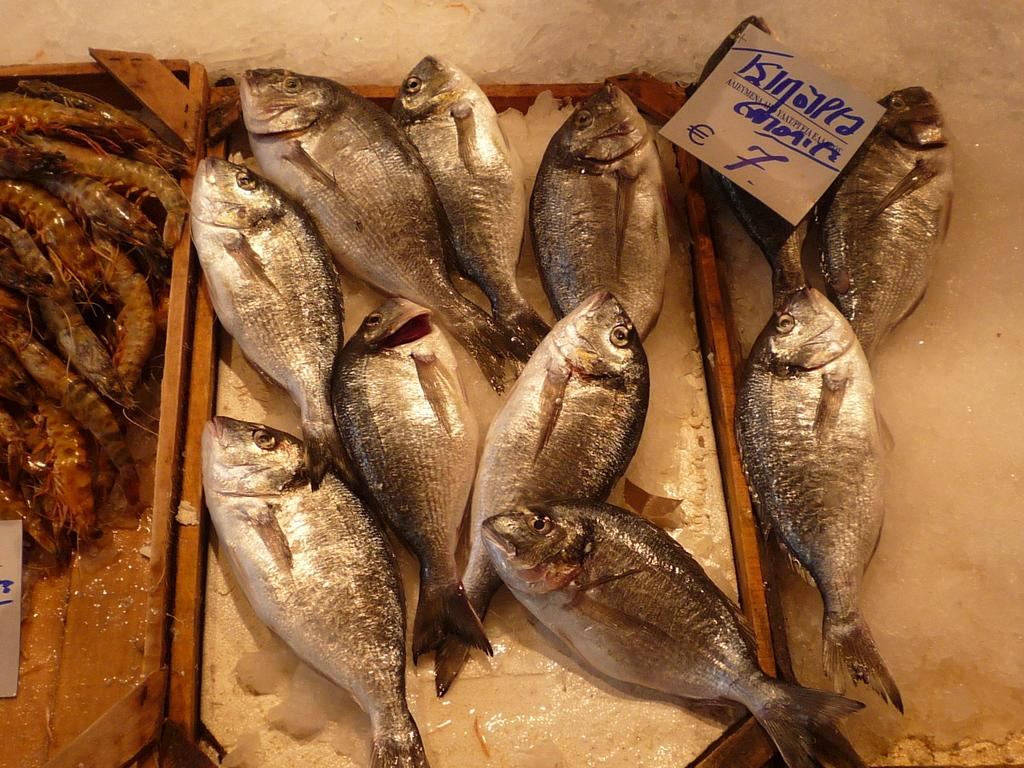What type of seafood can be seen on the wooden trays in the image? There are fishes and shrimps on the wooden trays in the image. How are the wooden trays being kept cool? The wooden trays are on ice in the image. What is located on the right side of the wooden trays? There is a paper on the right side of the trays. What type of watch is the beggar wearing in the image? There is no beggar or watch present in the image. What offer is being made by the fishmonger in the image? The image does not depict a fishmonger or any offer being made. 